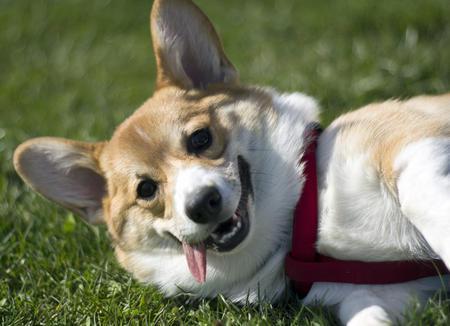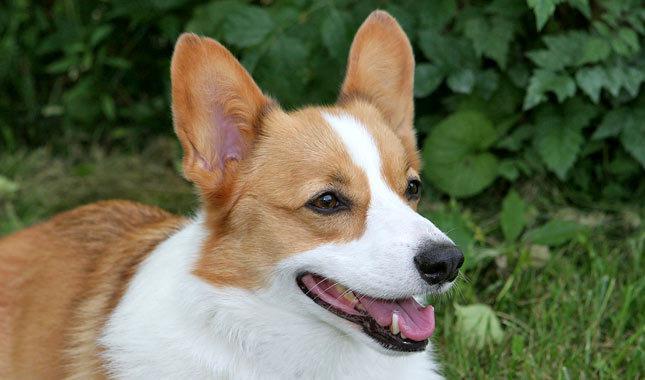The first image is the image on the left, the second image is the image on the right. Analyze the images presented: Is the assertion "One of the images contains a dog that is sitting." valid? Answer yes or no. No. 